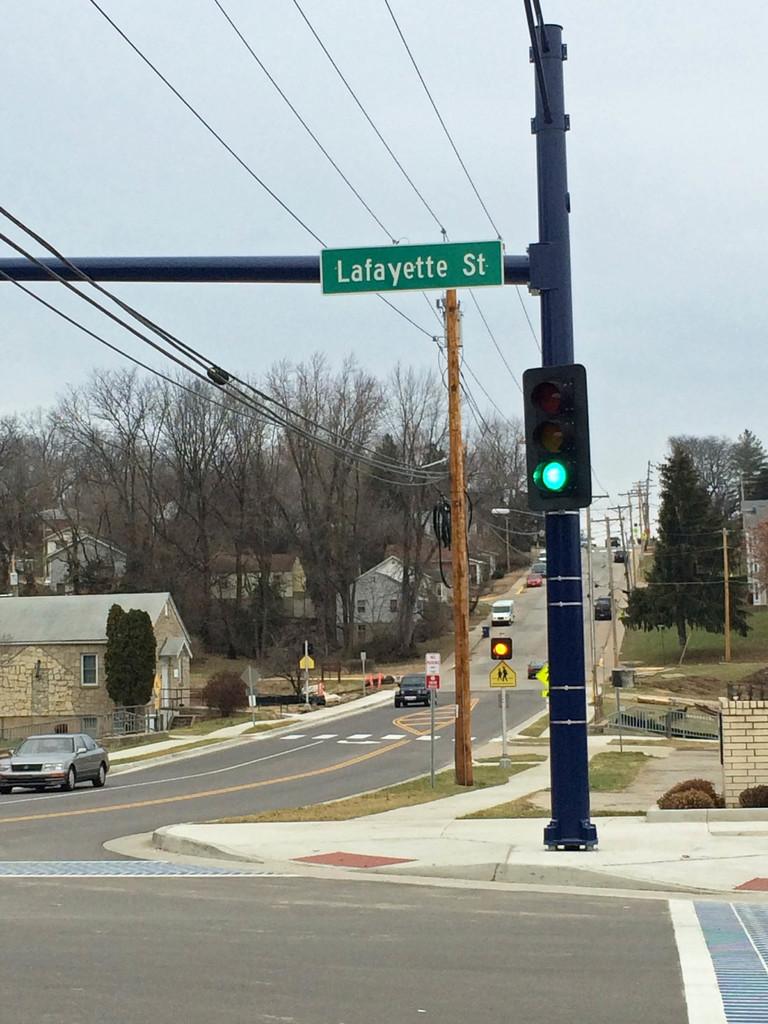What street is here?
Provide a short and direct response. Lafayette. What color is the text of the street sign?
Provide a short and direct response. Answering does not require reading text in the image. 